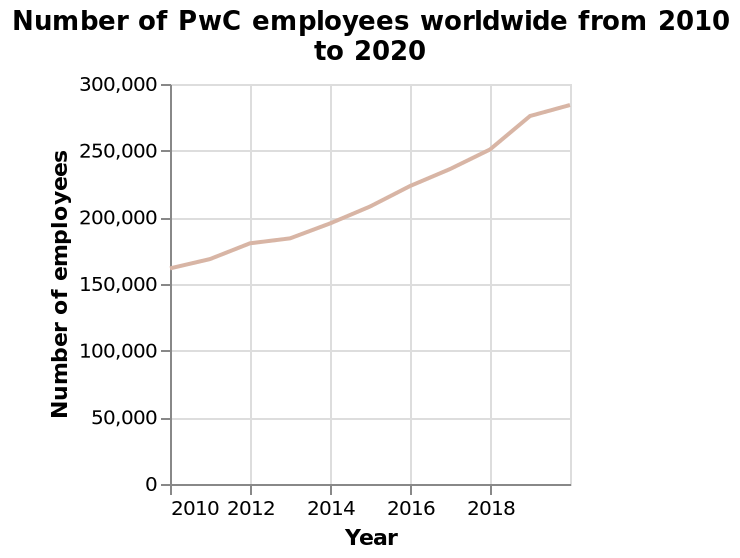<image>
Describe the following image in detail Number of PwC employees worldwide from 2010 to 2020 is a line chart. The x-axis plots Year on linear scale with a minimum of 2010 and a maximum of 2018 while the y-axis plots Number of employees along linear scale of range 0 to 300,000. What range is represented on the y-axis of the line chart? The y-axis of the line chart represents a range of 0 to 300,000. What is the minimum number of employees shown on the line chart? The line chart does not mention a minimum number of employees. 